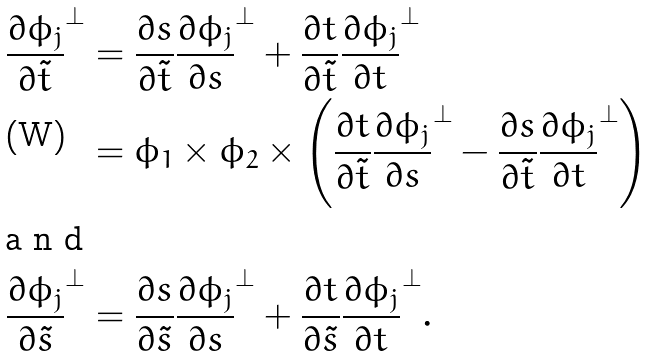Convert formula to latex. <formula><loc_0><loc_0><loc_500><loc_500>\frac { \partial \phi _ { j } } { \partial \tilde { t } } ^ { \perp } & = \frac { \partial s } { \partial \tilde { t } } \frac { \partial \phi _ { j } } { \partial s } ^ { \perp } + \frac { \partial t } { \partial \tilde { t } } \frac { \partial \phi _ { j } } { \partial t } ^ { \perp } \\ & = \phi _ { 1 } \times \phi _ { 2 } \times \left ( \frac { \partial t } { \partial \tilde { t } } \frac { \partial \phi _ { j } } { \partial s } ^ { \perp } - \frac { \partial s } { \partial \tilde { t } } \frac { \partial \phi _ { j } } { \partial t } ^ { \perp } \right ) \\ \intertext { a n d } \frac { \partial \phi _ { j } } { \partial \tilde { s } } ^ { \perp } & = \frac { \partial s } { \partial \tilde { s } } \frac { \partial \phi _ { j } } { \partial s } ^ { \perp } + \frac { \partial t } { \partial \tilde { s } } \frac { \partial \phi _ { j } } { \partial t } ^ { \perp } .</formula> 